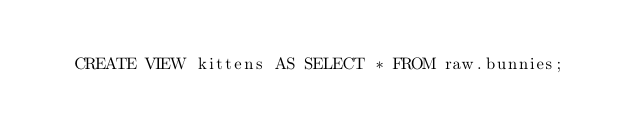<code> <loc_0><loc_0><loc_500><loc_500><_SQL_>
    CREATE VIEW kittens AS SELECT * FROM raw.bunnies;
</code> 